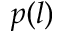Convert formula to latex. <formula><loc_0><loc_0><loc_500><loc_500>p ( l )</formula> 